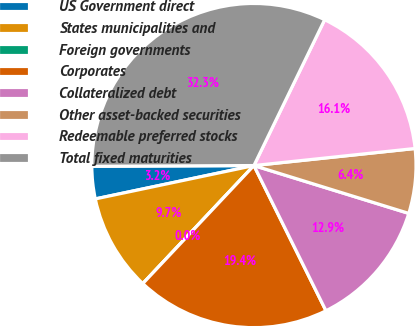Convert chart to OTSL. <chart><loc_0><loc_0><loc_500><loc_500><pie_chart><fcel>US Government direct<fcel>States municipalities and<fcel>Foreign governments<fcel>Corporates<fcel>Collateralized debt<fcel>Other asset-backed securities<fcel>Redeemable preferred stocks<fcel>Total fixed maturities<nl><fcel>3.23%<fcel>9.68%<fcel>0.0%<fcel>19.35%<fcel>12.9%<fcel>6.45%<fcel>16.13%<fcel>32.26%<nl></chart> 